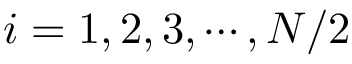Convert formula to latex. <formula><loc_0><loc_0><loc_500><loc_500>i = 1 , 2 , 3 , \cdots , N / 2</formula> 